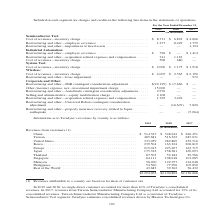According to Teradyne's financial document, What are the revenues from customers attributable to a country based on? location of customer site. The document states: ") Revenues attributable to a country are based on location of customer site...." Also, In which years is information as to Teradyne’s revenues by country provided? The document contains multiple relevant values: 2019, 2018, 2017. From the document: "2019 2018 2017 2019 2018 2017 2019 2018 2017..." Also, Which are the locations listed in the table? The document contains multiple relevant values: China, Taiwan, United States, Korea, Europe, Japan, Thailand, Singapore, Malaysia, Philippines, Rest of the World. From the document: "2,797 124,048 Philippines . 54,560 77,996 105,850 Rest of the World . 43,683 39,362 36,432 (in thousands) Revenues from customers (1): China . $ 514,3..." Also, How many different locations are listed in the table? Counting the relevant items in the document: China, Taiwan, United States, Korea, Europe, Japan, Thailand, Singapore, Malaysia, Philippines, Rest of the World, I find 11 instances. The key data points involved are: China, Europe, Japan. Also, can you calculate: What was the change in Rest of the World in 2019 from 2018? Based on the calculation: 43,683-39,362, the result is 4321 (in thousands). This is based on the information: "pines . 54,560 77,996 105,850 Rest of the World . 43,683 39,362 36,432 54,560 77,996 105,850 Rest of the World . 43,683 39,362 36,432..." The key data points involved are: 39,362, 43,683. Also, can you calculate: What was the percentage change in Rest of the World in 2019 from 2018? To answer this question, I need to perform calculations using the financial data. The calculation is: (43,683-39,362)/39,362, which equals 10.98 (percentage). This is based on the information: "pines . 54,560 77,996 105,850 Rest of the World . 43,683 39,362 36,432 54,560 77,996 105,850 Rest of the World . 43,683 39,362 36,432..." The key data points involved are: 39,362, 43,683. 